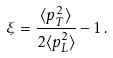<formula> <loc_0><loc_0><loc_500><loc_500>\xi = \frac { \langle p _ { T } ^ { 2 } \rangle } { 2 \langle p _ { L } ^ { 2 } \rangle } - 1 \, .</formula> 